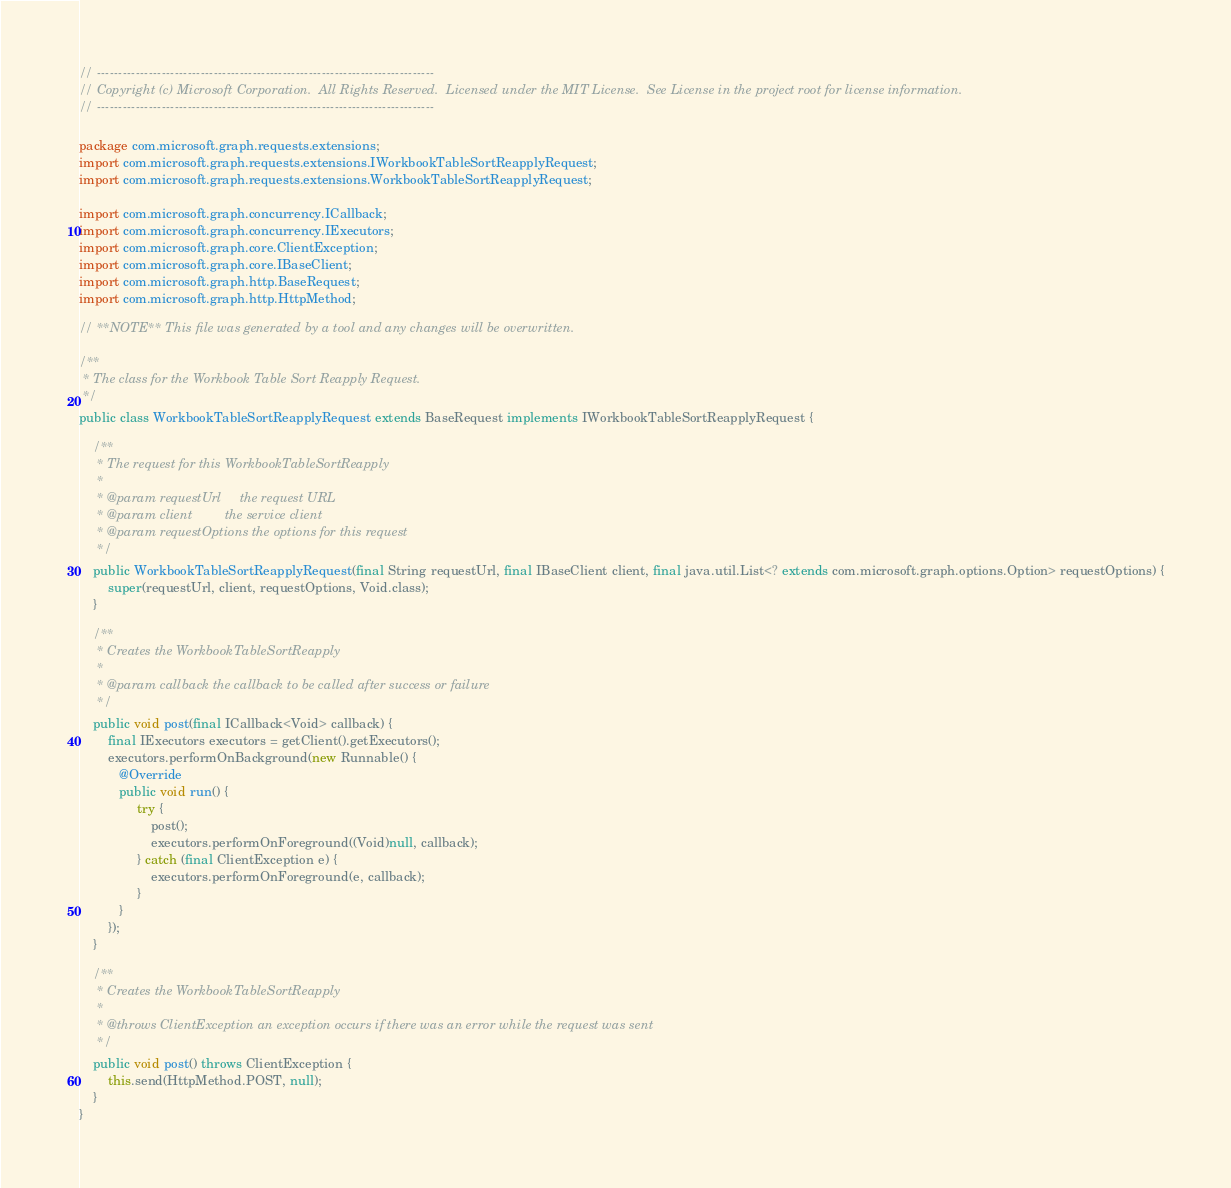Convert code to text. <code><loc_0><loc_0><loc_500><loc_500><_Java_>// ------------------------------------------------------------------------------
// Copyright (c) Microsoft Corporation.  All Rights Reserved.  Licensed under the MIT License.  See License in the project root for license information.
// ------------------------------------------------------------------------------

package com.microsoft.graph.requests.extensions;
import com.microsoft.graph.requests.extensions.IWorkbookTableSortReapplyRequest;
import com.microsoft.graph.requests.extensions.WorkbookTableSortReapplyRequest;

import com.microsoft.graph.concurrency.ICallback;
import com.microsoft.graph.concurrency.IExecutors;
import com.microsoft.graph.core.ClientException;
import com.microsoft.graph.core.IBaseClient;
import com.microsoft.graph.http.BaseRequest;
import com.microsoft.graph.http.HttpMethod;

// **NOTE** This file was generated by a tool and any changes will be overwritten.

/**
 * The class for the Workbook Table Sort Reapply Request.
 */
public class WorkbookTableSortReapplyRequest extends BaseRequest implements IWorkbookTableSortReapplyRequest {

    /**
     * The request for this WorkbookTableSortReapply
     *
     * @param requestUrl     the request URL
     * @param client         the service client
     * @param requestOptions the options for this request
     */
    public WorkbookTableSortReapplyRequest(final String requestUrl, final IBaseClient client, final java.util.List<? extends com.microsoft.graph.options.Option> requestOptions) {
        super(requestUrl, client, requestOptions, Void.class);
    }

    /**
     * Creates the WorkbookTableSortReapply
     *
     * @param callback the callback to be called after success or failure
     */
    public void post(final ICallback<Void> callback) {
        final IExecutors executors = getClient().getExecutors();
        executors.performOnBackground(new Runnable() {
           @Override
           public void run() {
                try {
                    post();
                    executors.performOnForeground((Void)null, callback);
                } catch (final ClientException e) {
                    executors.performOnForeground(e, callback);
                }
           }
        });
    }

    /**
     * Creates the WorkbookTableSortReapply
     *
     * @throws ClientException an exception occurs if there was an error while the request was sent
     */
    public void post() throws ClientException {
        this.send(HttpMethod.POST, null);
    }
}
</code> 